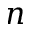Convert formula to latex. <formula><loc_0><loc_0><loc_500><loc_500>n</formula> 